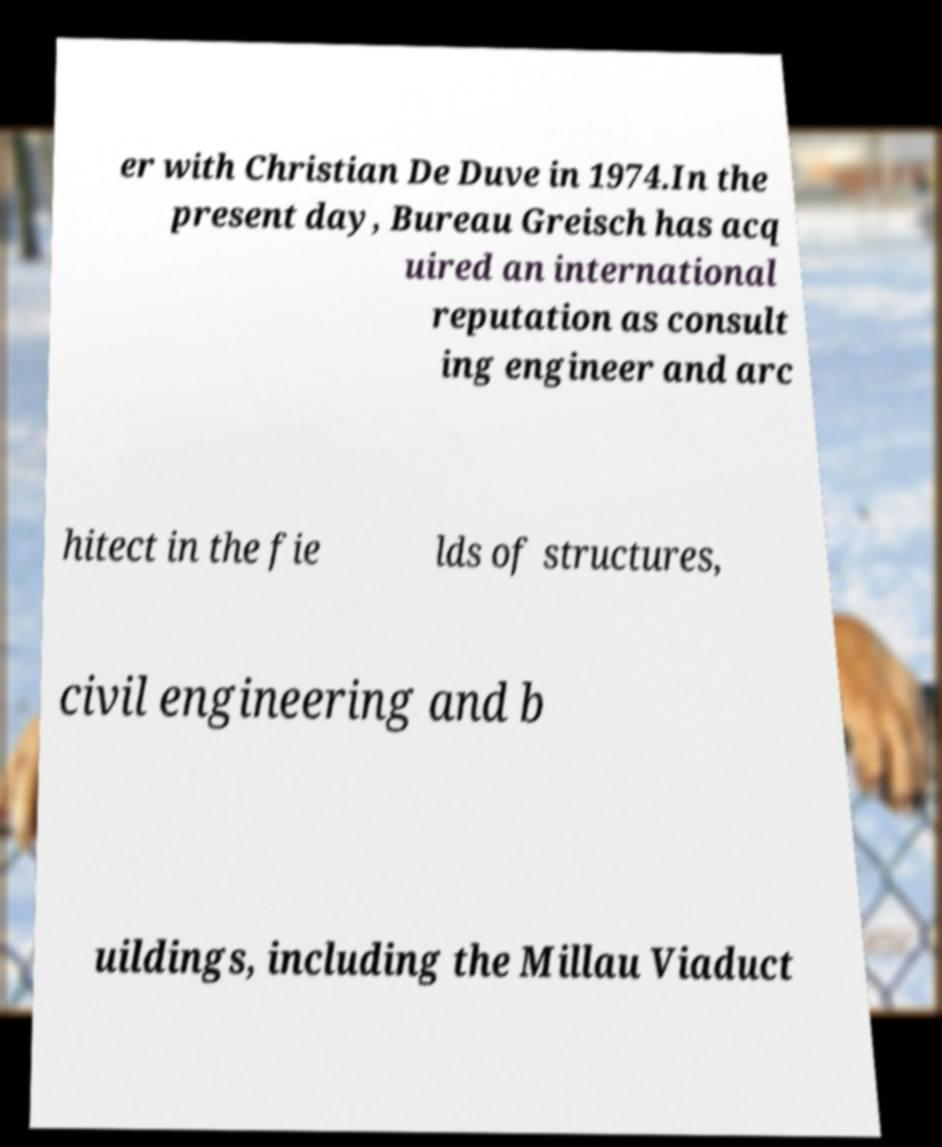There's text embedded in this image that I need extracted. Can you transcribe it verbatim? er with Christian De Duve in 1974.In the present day, Bureau Greisch has acq uired an international reputation as consult ing engineer and arc hitect in the fie lds of structures, civil engineering and b uildings, including the Millau Viaduct 